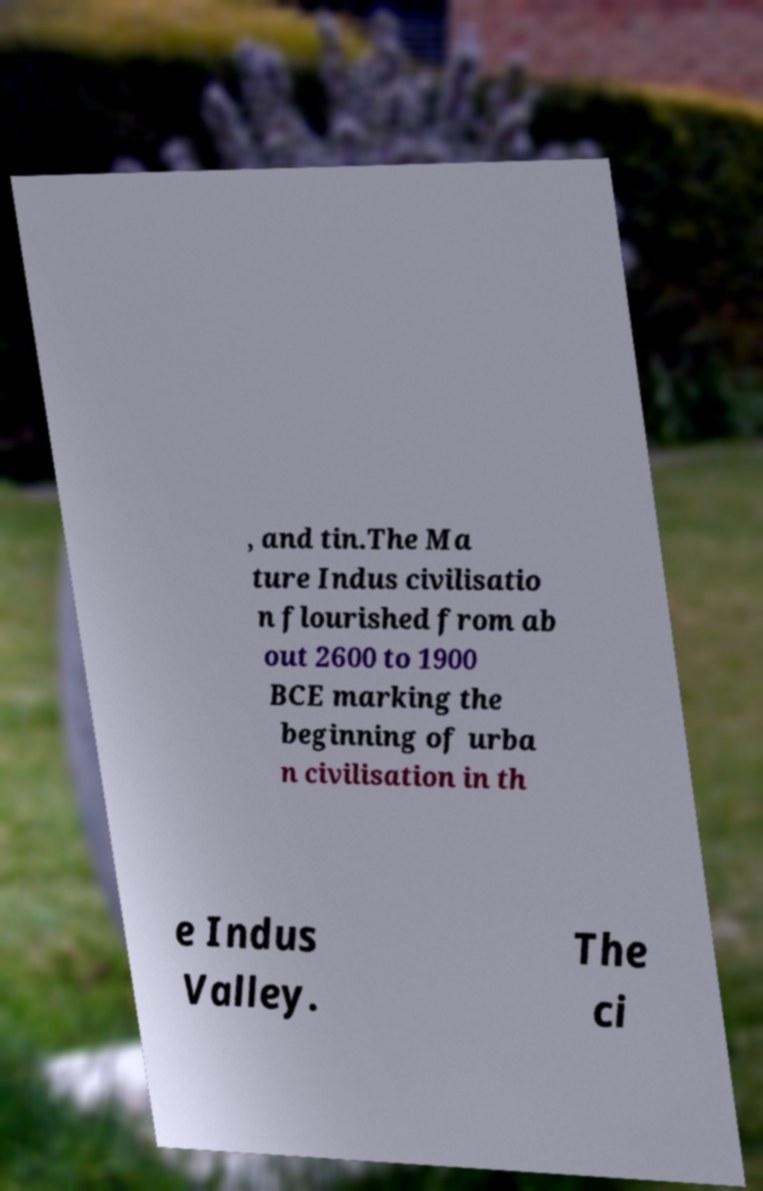What messages or text are displayed in this image? I need them in a readable, typed format. , and tin.The Ma ture Indus civilisatio n flourished from ab out 2600 to 1900 BCE marking the beginning of urba n civilisation in th e Indus Valley. The ci 